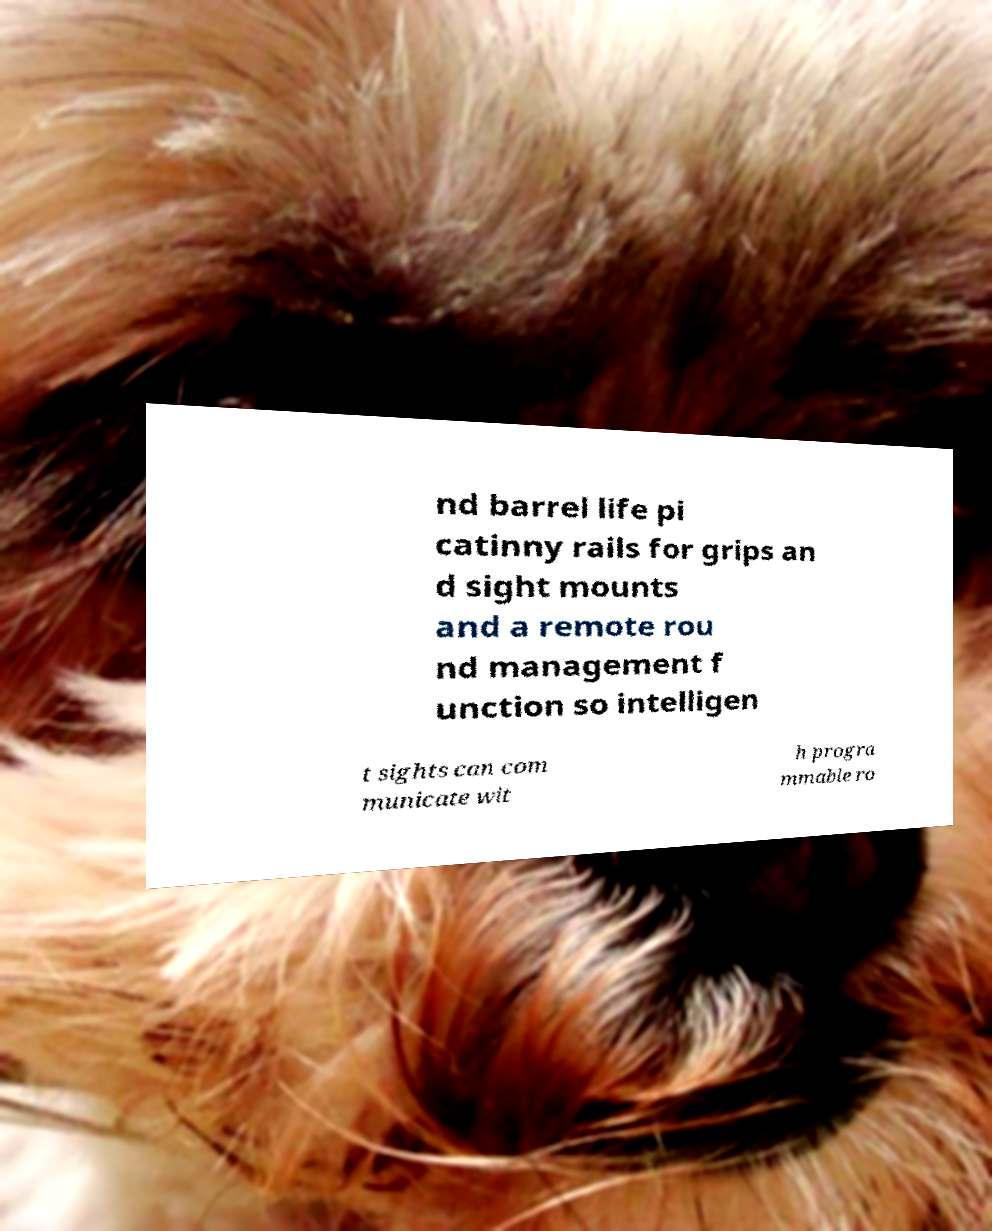What messages or text are displayed in this image? I need them in a readable, typed format. nd barrel life pi catinny rails for grips an d sight mounts and a remote rou nd management f unction so intelligen t sights can com municate wit h progra mmable ro 